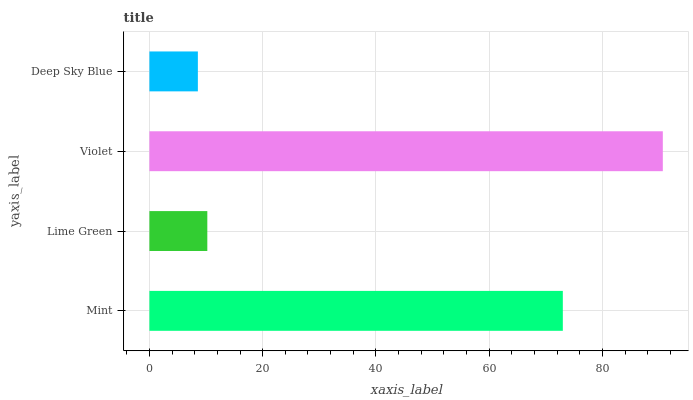Is Deep Sky Blue the minimum?
Answer yes or no. Yes. Is Violet the maximum?
Answer yes or no. Yes. Is Lime Green the minimum?
Answer yes or no. No. Is Lime Green the maximum?
Answer yes or no. No. Is Mint greater than Lime Green?
Answer yes or no. Yes. Is Lime Green less than Mint?
Answer yes or no. Yes. Is Lime Green greater than Mint?
Answer yes or no. No. Is Mint less than Lime Green?
Answer yes or no. No. Is Mint the high median?
Answer yes or no. Yes. Is Lime Green the low median?
Answer yes or no. Yes. Is Lime Green the high median?
Answer yes or no. No. Is Violet the low median?
Answer yes or no. No. 